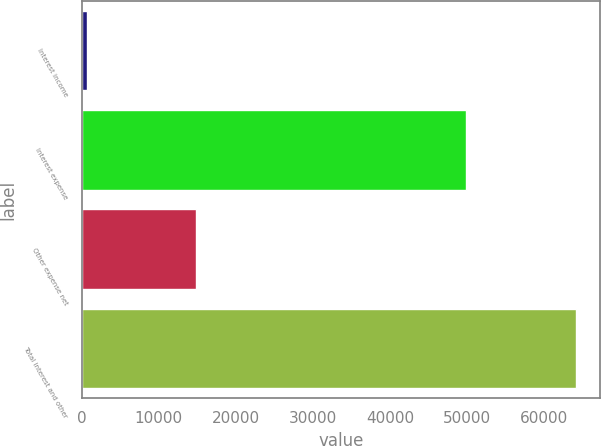<chart> <loc_0><loc_0><loc_500><loc_500><bar_chart><fcel>Interest income<fcel>Interest expense<fcel>Other expense net<fcel>Total interest and other<nl><fcel>650<fcel>49924<fcel>14836<fcel>64110<nl></chart> 